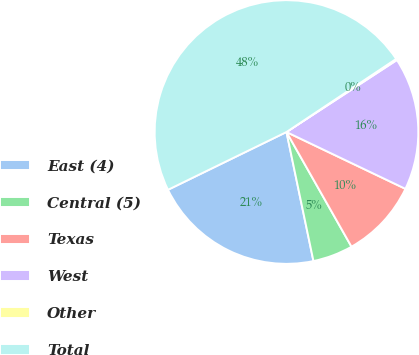Convert chart to OTSL. <chart><loc_0><loc_0><loc_500><loc_500><pie_chart><fcel>East (4)<fcel>Central (5)<fcel>Texas<fcel>West<fcel>Other<fcel>Total<nl><fcel>21.06%<fcel>4.93%<fcel>9.7%<fcel>16.29%<fcel>0.16%<fcel>47.87%<nl></chart> 